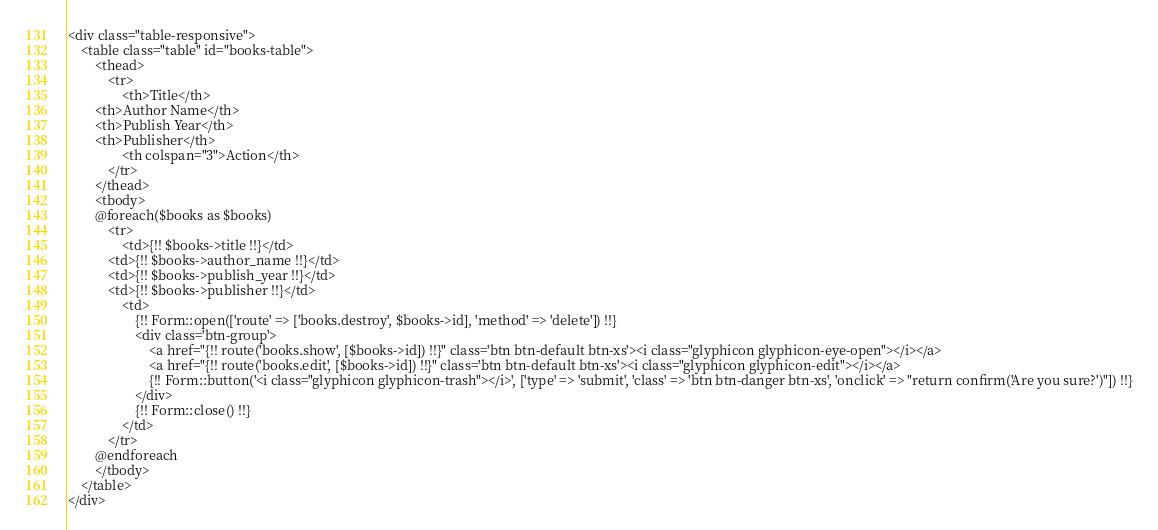Convert code to text. <code><loc_0><loc_0><loc_500><loc_500><_PHP_><div class="table-responsive">
    <table class="table" id="books-table">
        <thead>
            <tr>
                <th>Title</th>
        <th>Author Name</th>
        <th>Publish Year</th>
        <th>Publisher</th>
                <th colspan="3">Action</th>
            </tr>
        </thead>
        <tbody>
        @foreach($books as $books)
            <tr>
                <td>{!! $books->title !!}</td>
            <td>{!! $books->author_name !!}</td>
            <td>{!! $books->publish_year !!}</td>
            <td>{!! $books->publisher !!}</td>
                <td>
                    {!! Form::open(['route' => ['books.destroy', $books->id], 'method' => 'delete']) !!}
                    <div class='btn-group'>
                        <a href="{!! route('books.show', [$books->id]) !!}" class='btn btn-default btn-xs'><i class="glyphicon glyphicon-eye-open"></i></a>
                        <a href="{!! route('books.edit', [$books->id]) !!}" class='btn btn-default btn-xs'><i class="glyphicon glyphicon-edit"></i></a>
                        {!! Form::button('<i class="glyphicon glyphicon-trash"></i>', ['type' => 'submit', 'class' => 'btn btn-danger btn-xs', 'onclick' => "return confirm('Are you sure?')"]) !!}
                    </div>
                    {!! Form::close() !!}
                </td>
            </tr>
        @endforeach
        </tbody>
    </table>
</div>
</code> 